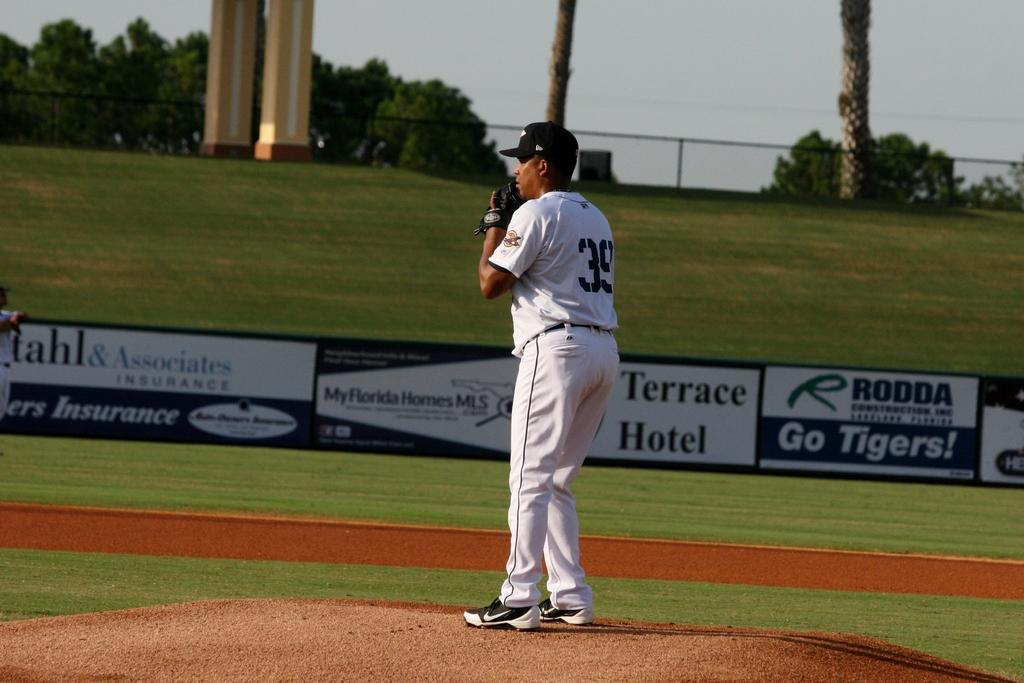<image>
Summarize the visual content of the image. number 39 getting ready to pitch and in the background fence signs for terrace hotel and rodda construction 